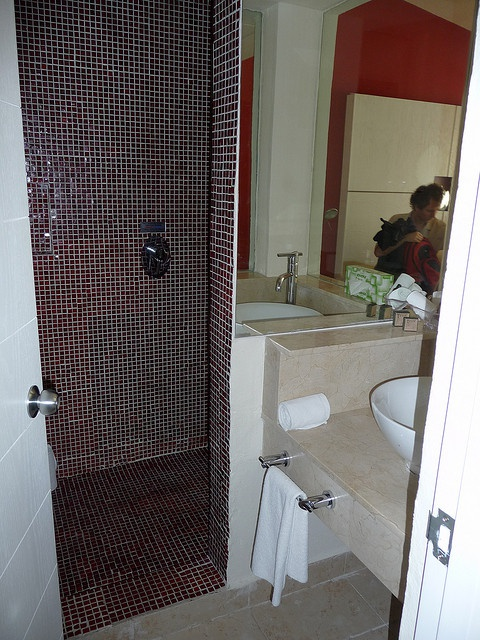Describe the objects in this image and their specific colors. I can see sink in gray, darkgray, and lightgray tones, people in gray and black tones, backpack in gray, black, and maroon tones, and sink in gray tones in this image. 